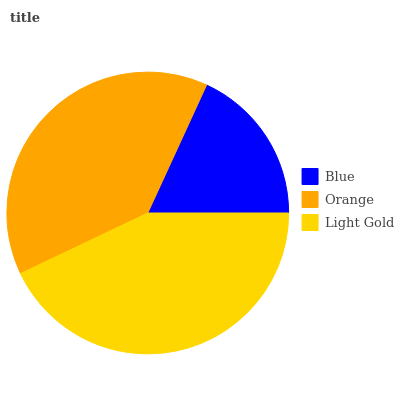Is Blue the minimum?
Answer yes or no. Yes. Is Light Gold the maximum?
Answer yes or no. Yes. Is Orange the minimum?
Answer yes or no. No. Is Orange the maximum?
Answer yes or no. No. Is Orange greater than Blue?
Answer yes or no. Yes. Is Blue less than Orange?
Answer yes or no. Yes. Is Blue greater than Orange?
Answer yes or no. No. Is Orange less than Blue?
Answer yes or no. No. Is Orange the high median?
Answer yes or no. Yes. Is Orange the low median?
Answer yes or no. Yes. Is Light Gold the high median?
Answer yes or no. No. Is Light Gold the low median?
Answer yes or no. No. 